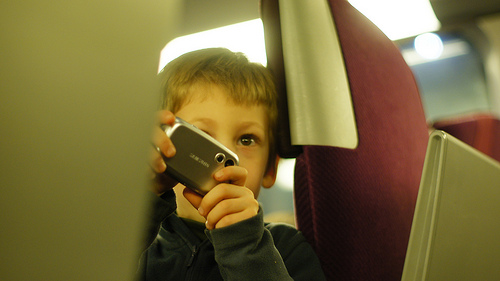<image>
Is there a boy in front of the camera? No. The boy is not in front of the camera. The spatial positioning shows a different relationship between these objects. 